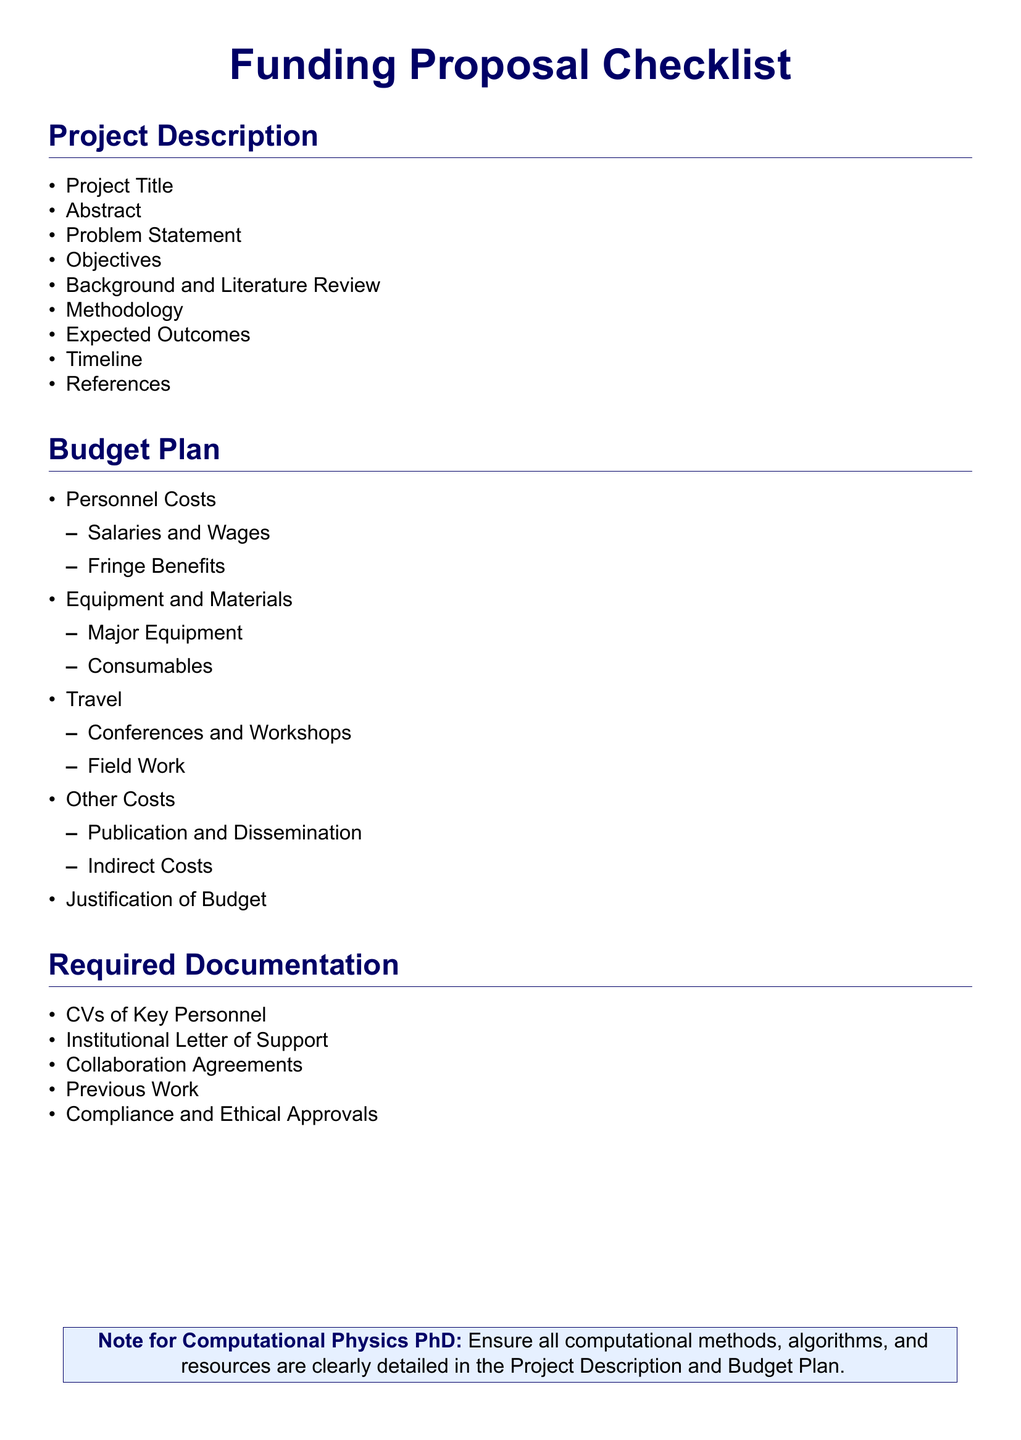What is the Project Title? The document includes a section for the Project Title under Project Description, where the title of the project should be specified.
Answer: Project Title How many main sections are in the Budget Plan? The Budget Plan contains four main sections listed in the document.
Answer: Four What are the first two items listed under Project Description? The first two items in the Project Description section are Project Title and Abstract.
Answer: Project Title, Abstract What type of costs is included under Personnel Costs? Personnel Costs include Salaries and Wages and Fringe Benefits as specified in the Budget Plan section.
Answer: Salaries and Wages, Fringe Benefits What is required documentation? Required Documentation lists essential documents needed for the proposal, as outlined in the document.
Answer: CVs of Key Personnel, Institutional Letter of Support, Collaboration Agreements, Previous Work, Compliance and Ethical Approvals What is noted for Computational Physics PhD? The note emphasizes the need to detail computational methods, algorithms, and resources in key sections.
Answer: Ensure all computational methods, algorithms, and resources are clearly detailed in the Project Description and Budget Plan What section follows the Background and Literature Review? The expected next item in the Project Description after the Background and Literature Review is Methodology.
Answer: Methodology How many items are listed under Required Documentation? The Required Documentation section lists five specific items needed for the proposal submission.
Answer: Five 